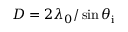<formula> <loc_0><loc_0><loc_500><loc_500>D = 2 \lambda _ { 0 } / \sin { \theta _ { i } }</formula> 